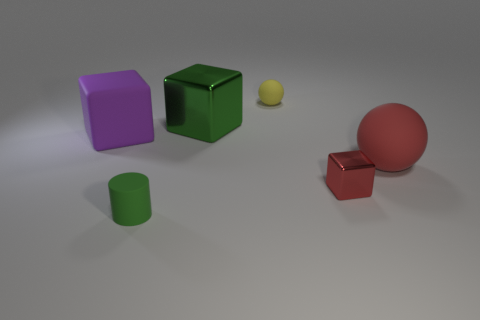What is the size of the red cube?
Your answer should be very brief. Small. Are there fewer cylinders behind the small yellow rubber sphere than small yellow spheres?
Your answer should be compact. Yes. How many brown rubber balls have the same size as the green cylinder?
Your response must be concise. 0. The object that is the same color as the large sphere is what shape?
Provide a short and direct response. Cube. Is the color of the large thing that is on the right side of the small red block the same as the metal cube that is behind the purple rubber thing?
Your response must be concise. No. What number of small rubber things are to the right of the large green shiny cube?
Ensure brevity in your answer.  1. There is a object that is the same color as the matte cylinder; what size is it?
Ensure brevity in your answer.  Large. Are there any blue metallic objects that have the same shape as the small yellow thing?
Your answer should be very brief. No. The cylinder that is the same size as the red metallic block is what color?
Offer a terse response. Green. Is the number of small matte balls on the right side of the cylinder less than the number of purple objects that are to the right of the small red thing?
Provide a succinct answer. No. 